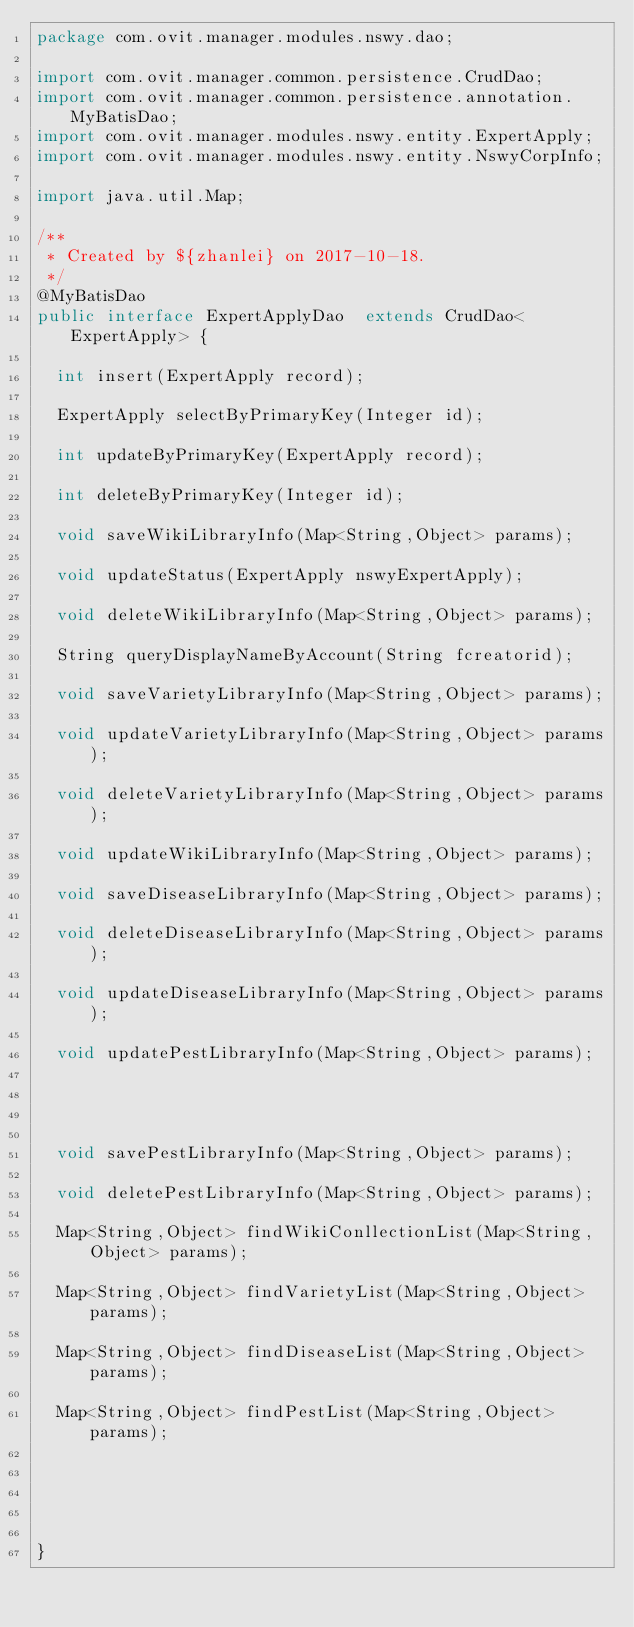Convert code to text. <code><loc_0><loc_0><loc_500><loc_500><_Java_>package com.ovit.manager.modules.nswy.dao;

import com.ovit.manager.common.persistence.CrudDao;
import com.ovit.manager.common.persistence.annotation.MyBatisDao;
import com.ovit.manager.modules.nswy.entity.ExpertApply;
import com.ovit.manager.modules.nswy.entity.NswyCorpInfo;

import java.util.Map;

/**
 * Created by ${zhanlei} on 2017-10-18.
 */
@MyBatisDao
public interface ExpertApplyDao  extends CrudDao<ExpertApply> {

	int insert(ExpertApply record);

	ExpertApply selectByPrimaryKey(Integer id);

	int updateByPrimaryKey(ExpertApply record);

	int deleteByPrimaryKey(Integer id);

	void saveWikiLibraryInfo(Map<String,Object> params);

	void updateStatus(ExpertApply nswyExpertApply);

	void deleteWikiLibraryInfo(Map<String,Object> params);

	String queryDisplayNameByAccount(String fcreatorid);

	void saveVarietyLibraryInfo(Map<String,Object> params);

	void updateVarietyLibraryInfo(Map<String,Object> params);

	void deleteVarietyLibraryInfo(Map<String,Object> params);

	void updateWikiLibraryInfo(Map<String,Object> params);

	void saveDiseaseLibraryInfo(Map<String,Object> params);

	void deleteDiseaseLibraryInfo(Map<String,Object> params);

	void updateDiseaseLibraryInfo(Map<String,Object> params);

	void updatePestLibraryInfo(Map<String,Object> params);




	void savePestLibraryInfo(Map<String,Object> params);

	void deletePestLibraryInfo(Map<String,Object> params);

	Map<String,Object> findWikiConllectionList(Map<String,Object> params);

	Map<String,Object> findVarietyList(Map<String,Object> params);

	Map<String,Object> findDiseaseList(Map<String,Object> params);

	Map<String,Object> findPestList(Map<String,Object> params);





}</code> 